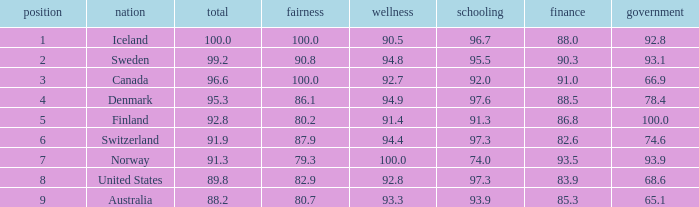What's the economics score with education being 92.0 91.0. 